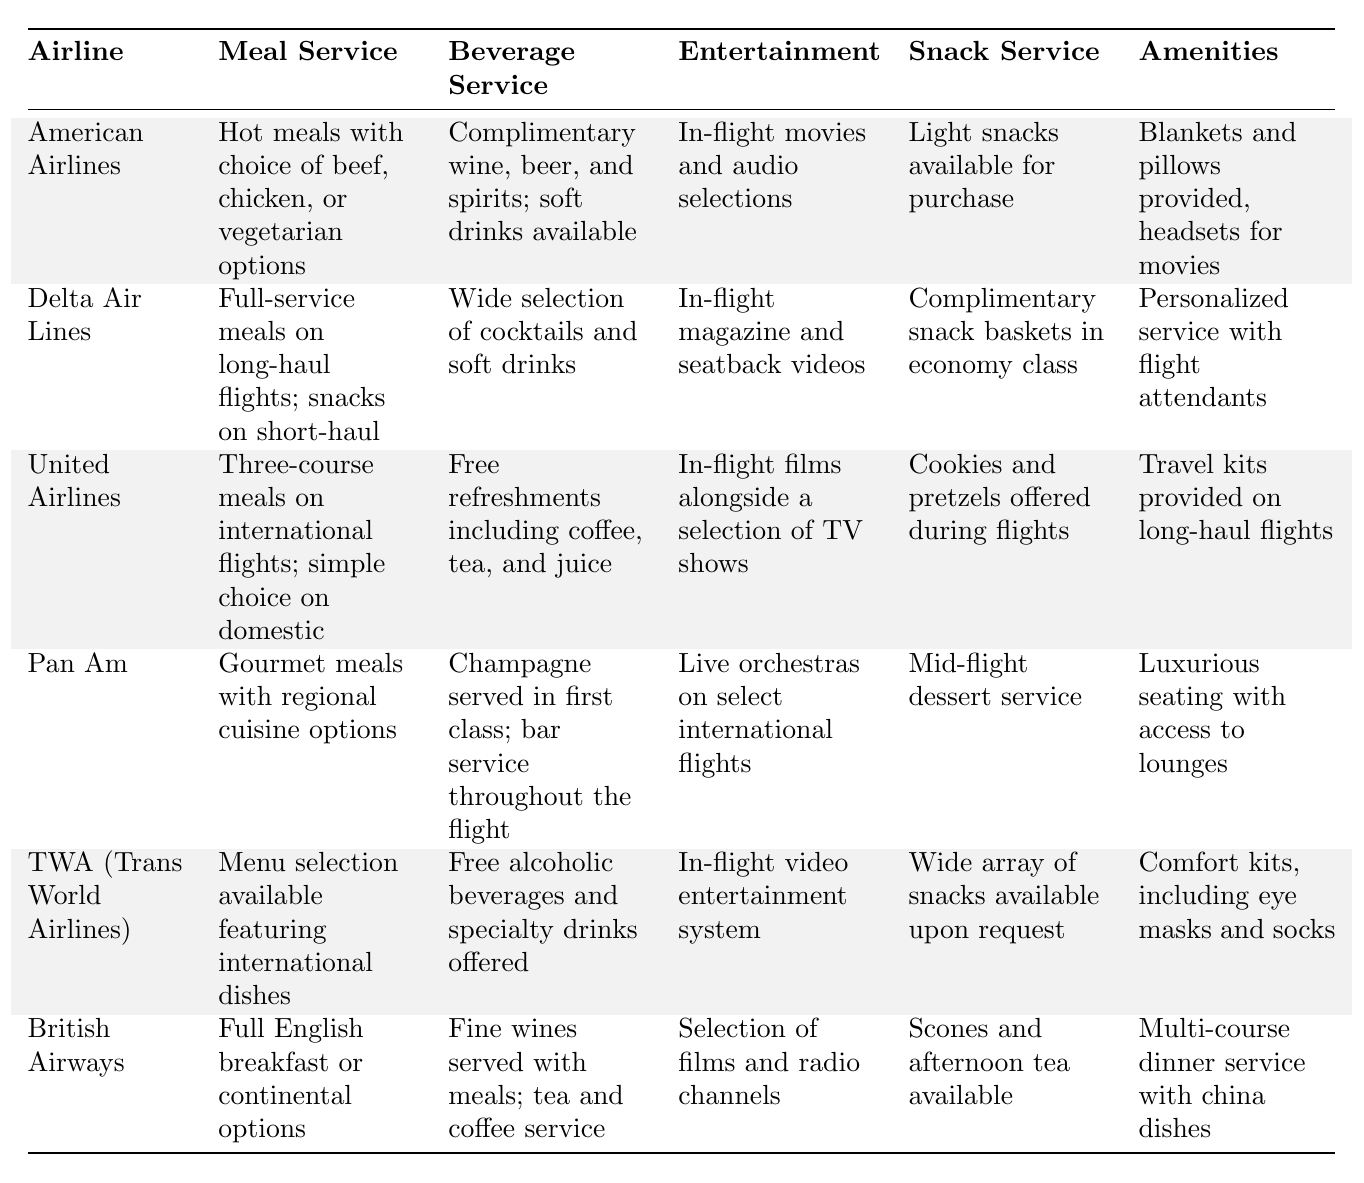What in-flight meal option is offered by American Airlines? According to the table, American Airlines offers hot meals with choices of beef, chicken, or vegetarian options.
Answer: Hot meals with choice of beef, chicken, or vegetarian options Which airline provides complimentary snack baskets in economy class? The table states that Delta Air Lines provides complimentary snack baskets in economy class.
Answer: Delta Air Lines Do all airlines provide free alcoholic beverages? By examining the beverage service in the table, it can be determined that not all airlines provide free alcoholic beverages; for example, American Airlines does not offer this.
Answer: No Which airline features live orchestras as part of their in-flight entertainment? The table indicates that Pan Am features live orchestras on select international flights as part of their in-flight entertainment.
Answer: Pan Am How many airlines include amenities like blankets or pillows? The table shows that American Airlines and United Airlines provide blankets and pillows, while TWA offers comfort kits. Thus, there are three airlines that provide such amenities.
Answer: Three airlines What is the average number of snack service offerings among the airlines listed? Counting the snack services listed for each airline, we see that there are six items in total: Light snacks, Complimentary snack baskets, Cookies and pretzels, Mid-flight dessert, Wide array of snacks, and Scones. Dividing this by the number of airlines (6) gives an average of 1 snack service per airline.
Answer: 1 snack service Does British Airways offer any type of afternoon tea service? The table indicates that British Airways offers scones and afternoon tea, confirming they do provide a type of afternoon tea service.
Answer: Yes Which airline has the most luxurious amenities according to the table? Comparing the amenities, Pan Am is noted for luxurious seating with access to lounges, which is a higher level of service than the rest.
Answer: Pan Am What type of meal service does United Airlines offer on domestic flights? The table states that United Airlines offers a simple choice of meals on domestic flights, as opposed to their three-course meals on international flights.
Answer: Simple choice Which airline offers travel kits, including eye masks and socks? The table specifically mentions that TWA (Trans World Airlines) provides comfort kits, which include eye masks and socks.
Answer: TWA (Trans World Airlines) What is unique about the beverage service on Pan Am flights? According to the table, Pan Am serves champagne in first class and has bar service throughout the flight, which is noted as a unique offering among the airlines.
Answer: Champagne in first class and bar service 